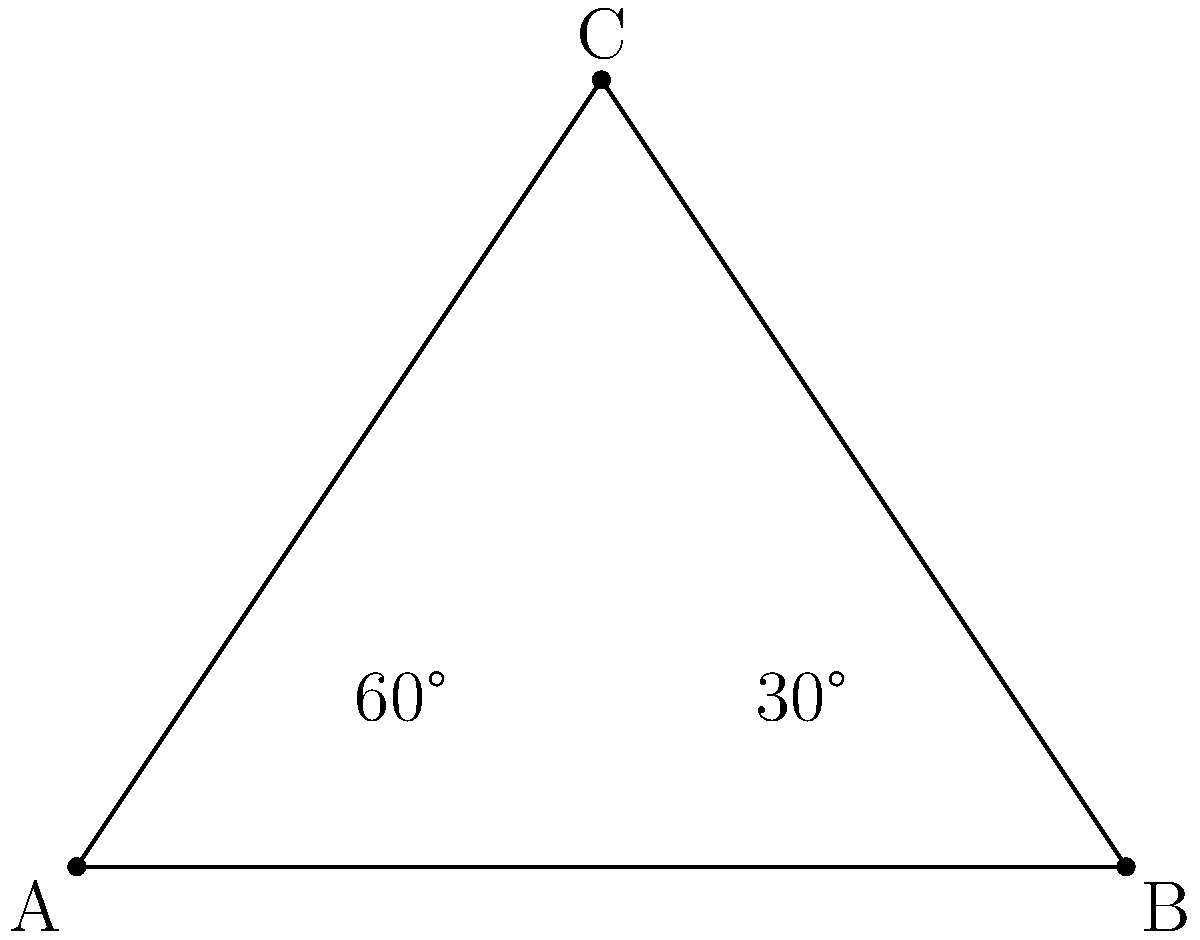In a network diagram representing the connection between three data centers A, B, and C, the paths AB and BC intersect at point C, forming a triangle. If the angle between AC and BC is 30°, and the angle between AB and AC is 60°, what is the measure of angle ABC? To solve this problem, we'll use the properties of triangles:

1. In any triangle, the sum of all interior angles is always 180°.

2. We are given two angles in the triangle:
   - Angle CAB = 60°
   - Angle BCA = 30°

3. Let's call the angle we're looking for (angle ABC) as x°.

4. Using the property that the sum of all angles in a triangle is 180°, we can set up an equation:
   
   $$60° + 30° + x° = 180°$$

5. Simplify the left side of the equation:
   
   $$90° + x° = 180°$$

6. Subtract 90° from both sides:
   
   $$x° = 180° - 90° = 90°$$

Therefore, the measure of angle ABC is 90°.
Answer: 90° 